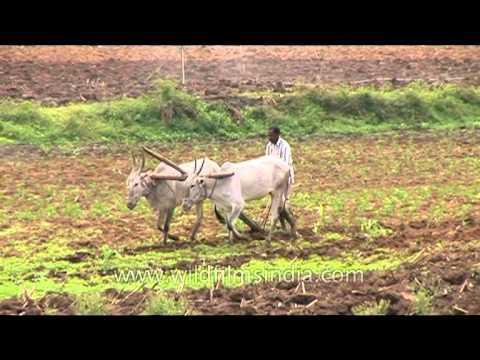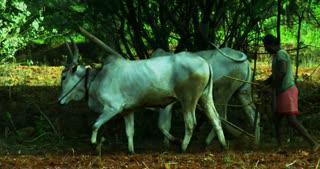The first image is the image on the left, the second image is the image on the right. Examine the images to the left and right. Is the description "The left and right image contains the same number of ox pulling a tilt guided by at man and one of the men is not wearing a hat." accurate? Answer yes or no. Yes. The first image is the image on the left, the second image is the image on the right. Examine the images to the left and right. Is the description "Each image shows one person behind two hitched white oxen, and the right image shows oxen moving leftward." accurate? Answer yes or no. Yes. 